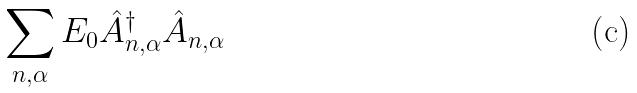<formula> <loc_0><loc_0><loc_500><loc_500>\sum _ { n , \alpha } E _ { 0 } \hat { A } _ { n , \alpha } ^ { \dagger } \hat { A } _ { n , \alpha }</formula> 